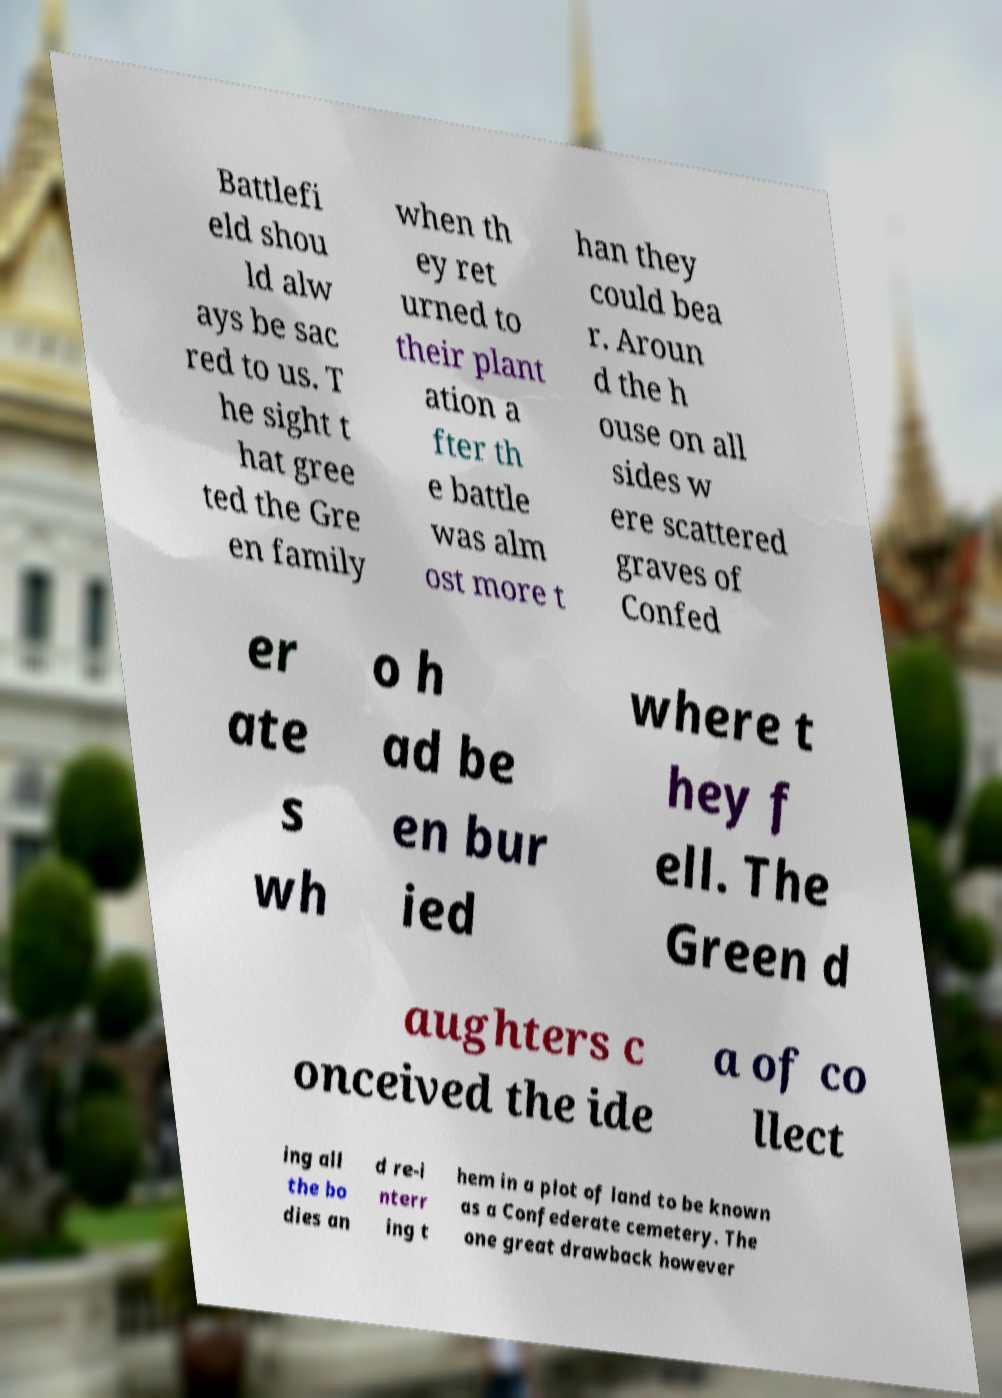What messages or text are displayed in this image? I need them in a readable, typed format. Battlefi eld shou ld alw ays be sac red to us. T he sight t hat gree ted the Gre en family when th ey ret urned to their plant ation a fter th e battle was alm ost more t han they could bea r. Aroun d the h ouse on all sides w ere scattered graves of Confed er ate s wh o h ad be en bur ied where t hey f ell. The Green d aughters c onceived the ide a of co llect ing all the bo dies an d re-i nterr ing t hem in a plot of land to be known as a Confederate cemetery. The one great drawback however 